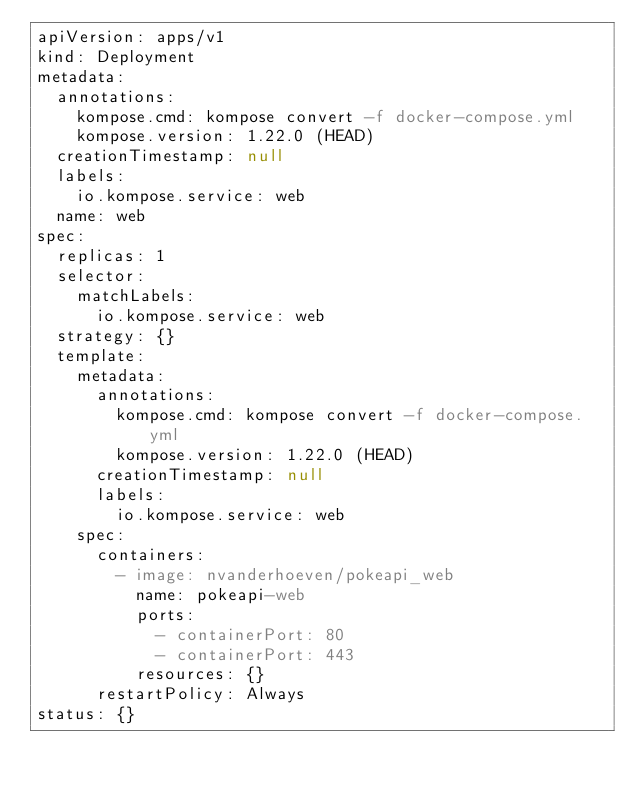Convert code to text. <code><loc_0><loc_0><loc_500><loc_500><_YAML_>apiVersion: apps/v1
kind: Deployment
metadata:
  annotations:
    kompose.cmd: kompose convert -f docker-compose.yml
    kompose.version: 1.22.0 (HEAD)
  creationTimestamp: null
  labels:
    io.kompose.service: web
  name: web
spec:
  replicas: 1
  selector:
    matchLabels:
      io.kompose.service: web
  strategy: {}
  template:
    metadata:
      annotations:
        kompose.cmd: kompose convert -f docker-compose.yml
        kompose.version: 1.22.0 (HEAD)
      creationTimestamp: null
      labels:
        io.kompose.service: web
    spec:
      containers:
        - image: nvanderhoeven/pokeapi_web
          name: pokeapi-web
          ports:
            - containerPort: 80
            - containerPort: 443
          resources: {}
      restartPolicy: Always
status: {}
</code> 